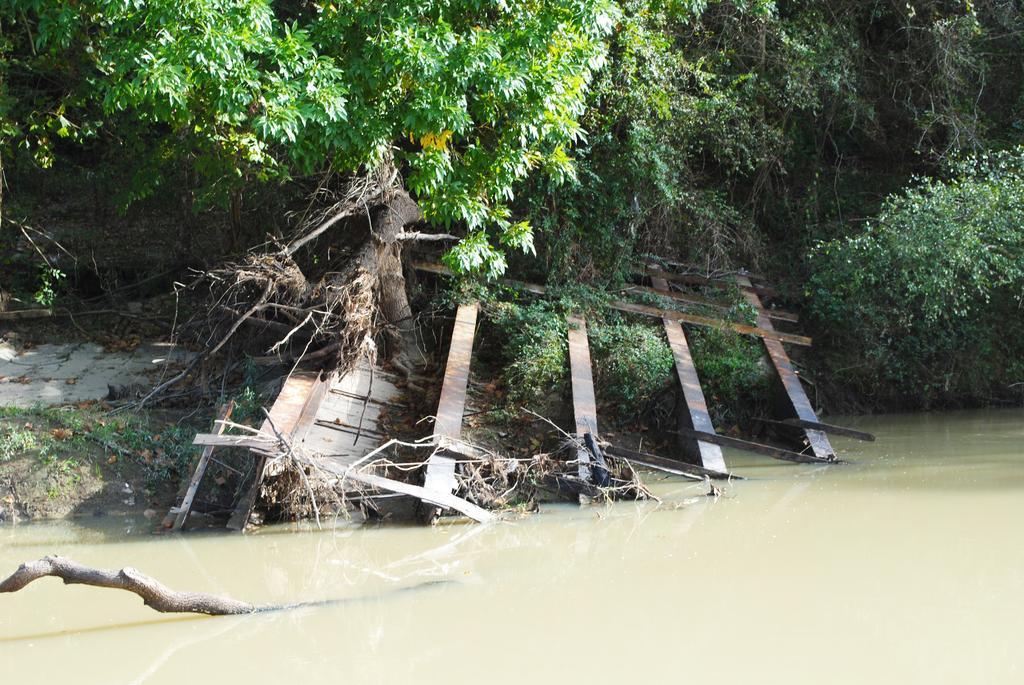Please provide a concise description of this image. At the bottom of this image, there is a branch of a tree in the water. In the background, there are trees, plants, dry leaves, wood and iron objects. 